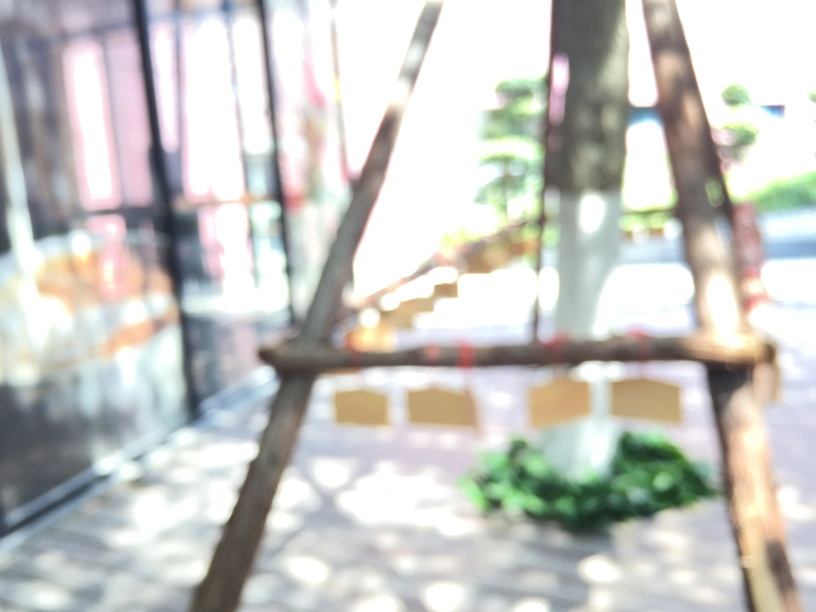Is any useful information extractable from the photo? While the photo is blurry and details are not clear, it appears to be an outdoor setting with bright lighting. Specific information cannot be extracted but the blur suggests motion or a camera focus issue. 